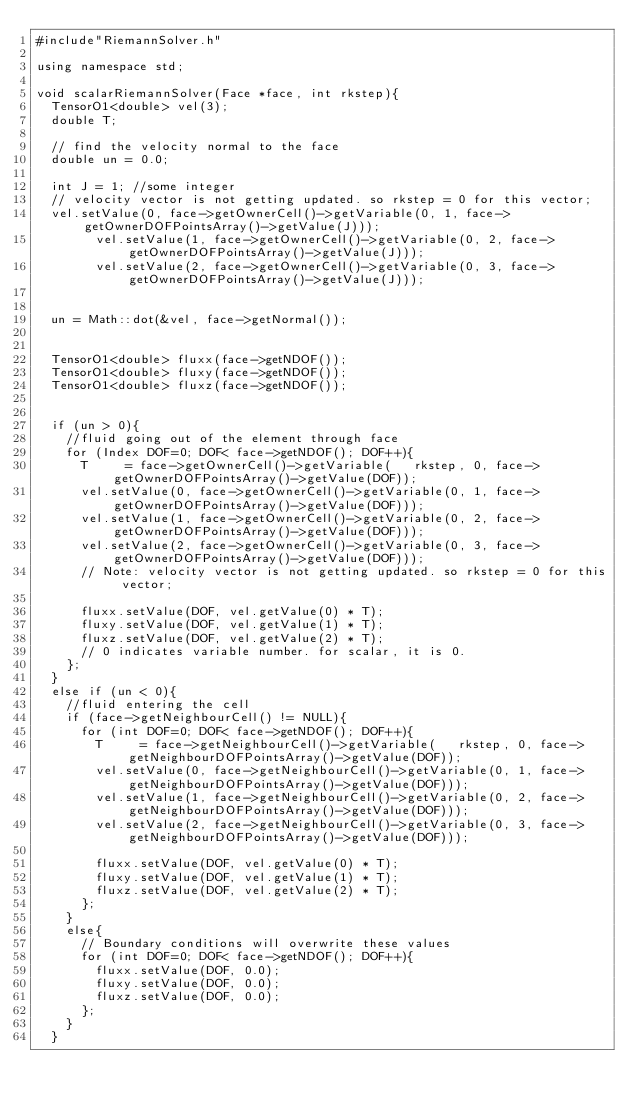<code> <loc_0><loc_0><loc_500><loc_500><_C++_>#include"RiemannSolver.h"

using namespace std;

void scalarRiemannSolver(Face *face, int rkstep){
	TensorO1<double> vel(3);
	double T;

	// find the velocity normal to the face
	double un = 0.0;

	int J = 1; //some integer
	// velocity vector is not getting updated. so rkstep = 0 for this vector;
	vel.setValue(0, face->getOwnerCell()->getVariable(0, 1, face->getOwnerDOFPointsArray()->getValue(J)));
        vel.setValue(1, face->getOwnerCell()->getVariable(0, 2, face->getOwnerDOFPointsArray()->getValue(J)));
        vel.setValue(2, face->getOwnerCell()->getVariable(0, 3, face->getOwnerDOFPointsArray()->getValue(J)));


	un = Math::dot(&vel, face->getNormal());


	TensorO1<double> fluxx(face->getNDOF());
	TensorO1<double> fluxy(face->getNDOF());
	TensorO1<double> fluxz(face->getNDOF());


	if (un > 0){ 
		//fluid going out of the element through face
		for (Index DOF=0; DOF< face->getNDOF(); DOF++){
			T     = face->getOwnerCell()->getVariable(   rkstep, 0, face->getOwnerDOFPointsArray()->getValue(DOF));
			vel.setValue(0, face->getOwnerCell()->getVariable(0, 1, face->getOwnerDOFPointsArray()->getValue(DOF)));
			vel.setValue(1, face->getOwnerCell()->getVariable(0, 2, face->getOwnerDOFPointsArray()->getValue(DOF)));
			vel.setValue(2, face->getOwnerCell()->getVariable(0, 3, face->getOwnerDOFPointsArray()->getValue(DOF)));
			// Note: velocity vector is not getting updated. so rkstep = 0 for this vector;

			fluxx.setValue(DOF, vel.getValue(0) * T);
			fluxy.setValue(DOF, vel.getValue(1) * T);
			fluxz.setValue(DOF, vel.getValue(2) * T);
			// 0 indicates variable number. for scalar, it is 0.
		};
	}
	else if (un < 0){
		//fluid entering the cell
		if (face->getNeighbourCell() != NULL){
			for (int DOF=0; DOF< face->getNDOF(); DOF++){
				T     = face->getNeighbourCell()->getVariable(   rkstep, 0, face->getNeighbourDOFPointsArray()->getValue(DOF));
				vel.setValue(0, face->getNeighbourCell()->getVariable(0, 1, face->getNeighbourDOFPointsArray()->getValue(DOF)));
				vel.setValue(1, face->getNeighbourCell()->getVariable(0, 2, face->getNeighbourDOFPointsArray()->getValue(DOF)));
				vel.setValue(2, face->getNeighbourCell()->getVariable(0, 3, face->getNeighbourDOFPointsArray()->getValue(DOF)));

				fluxx.setValue(DOF, vel.getValue(0) * T);
				fluxy.setValue(DOF, vel.getValue(1) * T);
				fluxz.setValue(DOF, vel.getValue(2) * T);
			};
		}
		else{
			// Boundary conditions will overwrite these values
			for (int DOF=0; DOF< face->getNDOF(); DOF++){
				fluxx.setValue(DOF, 0.0);
				fluxy.setValue(DOF, 0.0);
				fluxz.setValue(DOF, 0.0);
			};
		}
	}</code> 